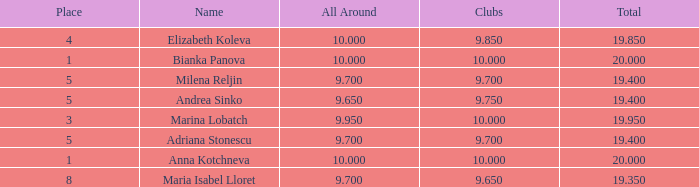Identify the lowest-level clubs with a position greater than 5 and an overall score exceeding 9.7. None. 